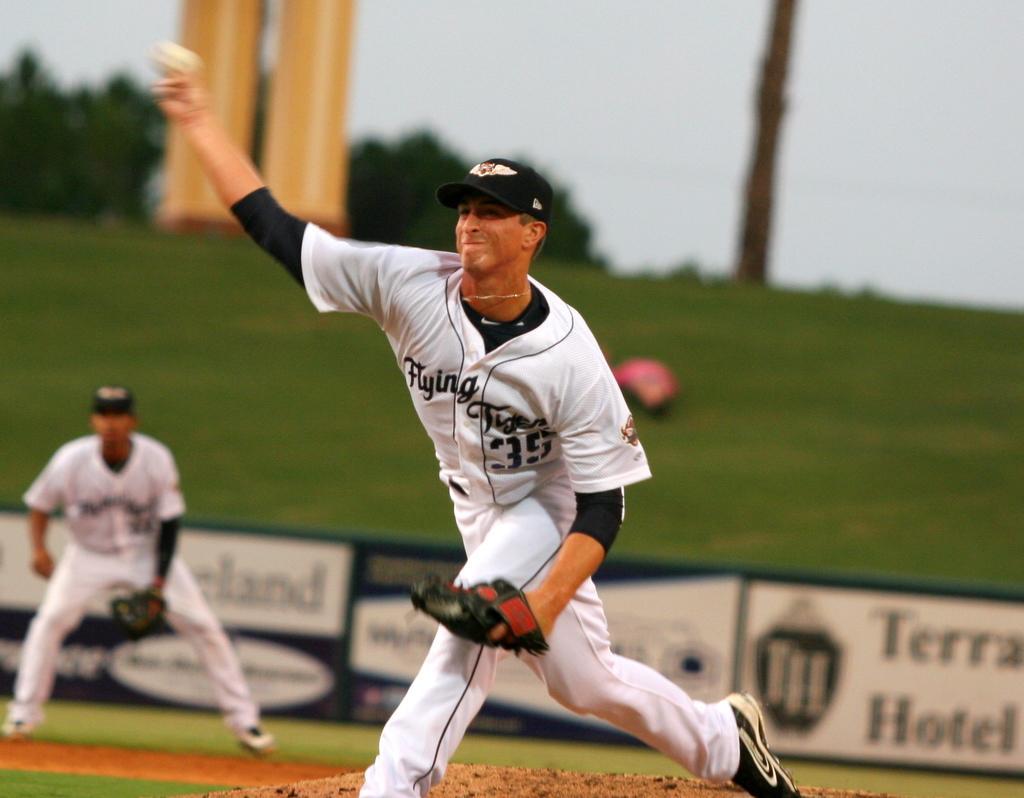How would you summarize this image in a sentence or two? In this image there is the sky towards the top of the image, there are trees towards the left of the image, there are objects towards the top of the image, there is the grass, there is an object on the grass, there are boards, there is text on the boards, there is a playground, there is a man standing, there is a man standing and throwing a ball. 